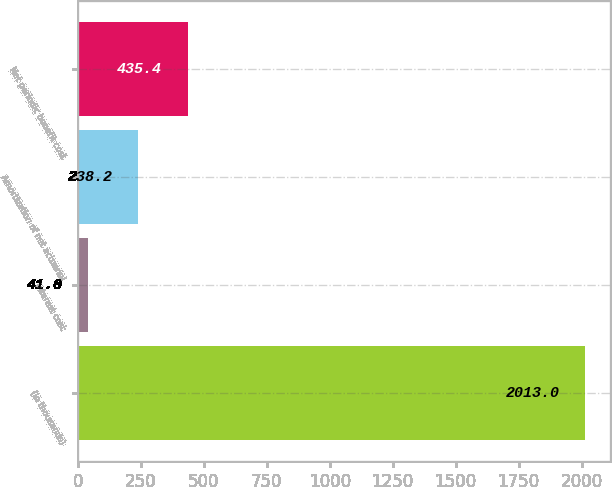Convert chart to OTSL. <chart><loc_0><loc_0><loc_500><loc_500><bar_chart><fcel>(In thousands)<fcel>Interest cost<fcel>Amortization of net actuarial<fcel>Net periodic benefit cost<nl><fcel>2013<fcel>41<fcel>238.2<fcel>435.4<nl></chart> 